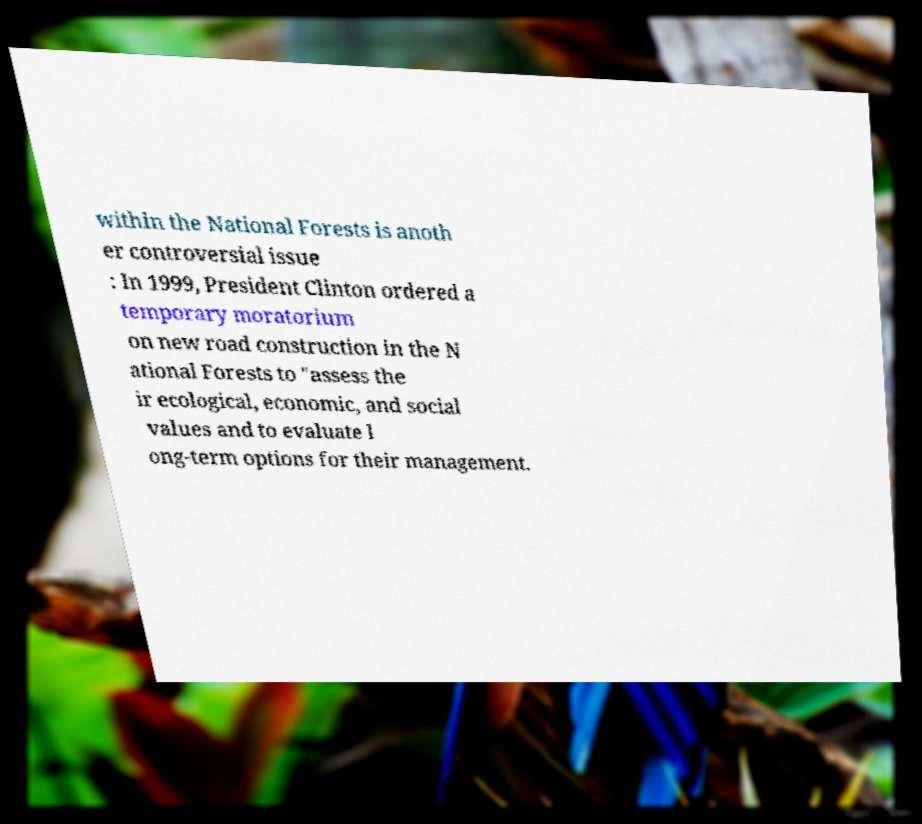Could you assist in decoding the text presented in this image and type it out clearly? within the National Forests is anoth er controversial issue : In 1999, President Clinton ordered a temporary moratorium on new road construction in the N ational Forests to "assess the ir ecological, economic, and social values and to evaluate l ong-term options for their management. 